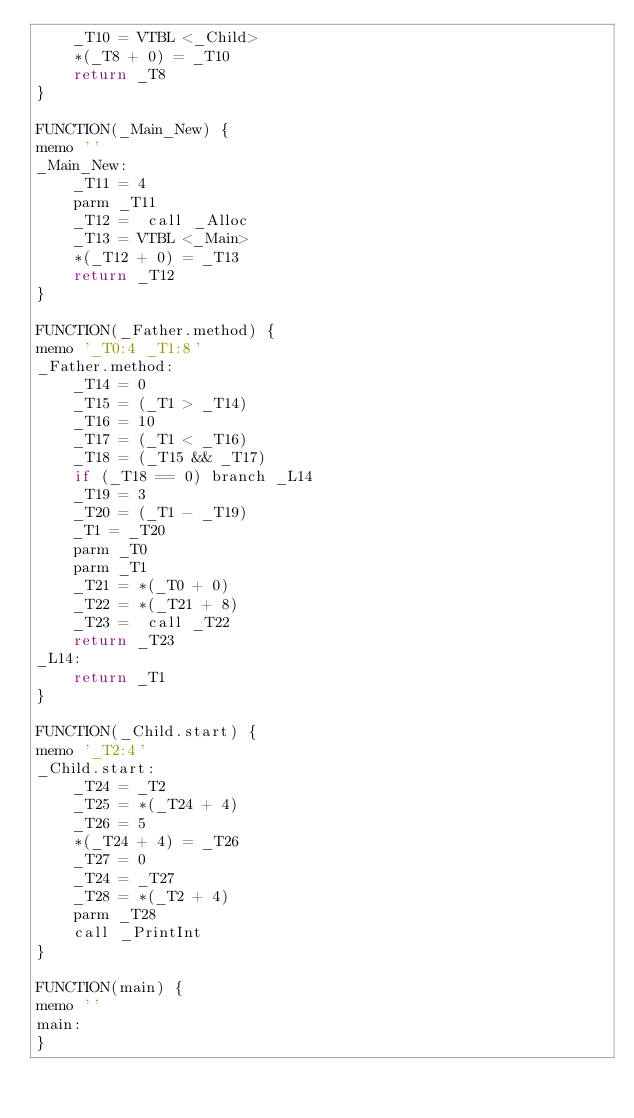<code> <loc_0><loc_0><loc_500><loc_500><_Python_>    _T10 = VTBL <_Child>
    *(_T8 + 0) = _T10
    return _T8
}

FUNCTION(_Main_New) {
memo ''
_Main_New:
    _T11 = 4
    parm _T11
    _T12 =  call _Alloc
    _T13 = VTBL <_Main>
    *(_T12 + 0) = _T13
    return _T12
}

FUNCTION(_Father.method) {
memo '_T0:4 _T1:8'
_Father.method:
    _T14 = 0
    _T15 = (_T1 > _T14)
    _T16 = 10
    _T17 = (_T1 < _T16)
    _T18 = (_T15 && _T17)
    if (_T18 == 0) branch _L14
    _T19 = 3
    _T20 = (_T1 - _T19)
    _T1 = _T20
    parm _T0
    parm _T1
    _T21 = *(_T0 + 0)
    _T22 = *(_T21 + 8)
    _T23 =  call _T22
    return _T23
_L14:
    return _T1
}

FUNCTION(_Child.start) {
memo '_T2:4'
_Child.start:
    _T24 = _T2
    _T25 = *(_T24 + 4)
    _T26 = 5
    *(_T24 + 4) = _T26
    _T27 = 0
    _T24 = _T27
    _T28 = *(_T2 + 4)
    parm _T28
    call _PrintInt
}

FUNCTION(main) {
memo ''
main:
}

</code> 